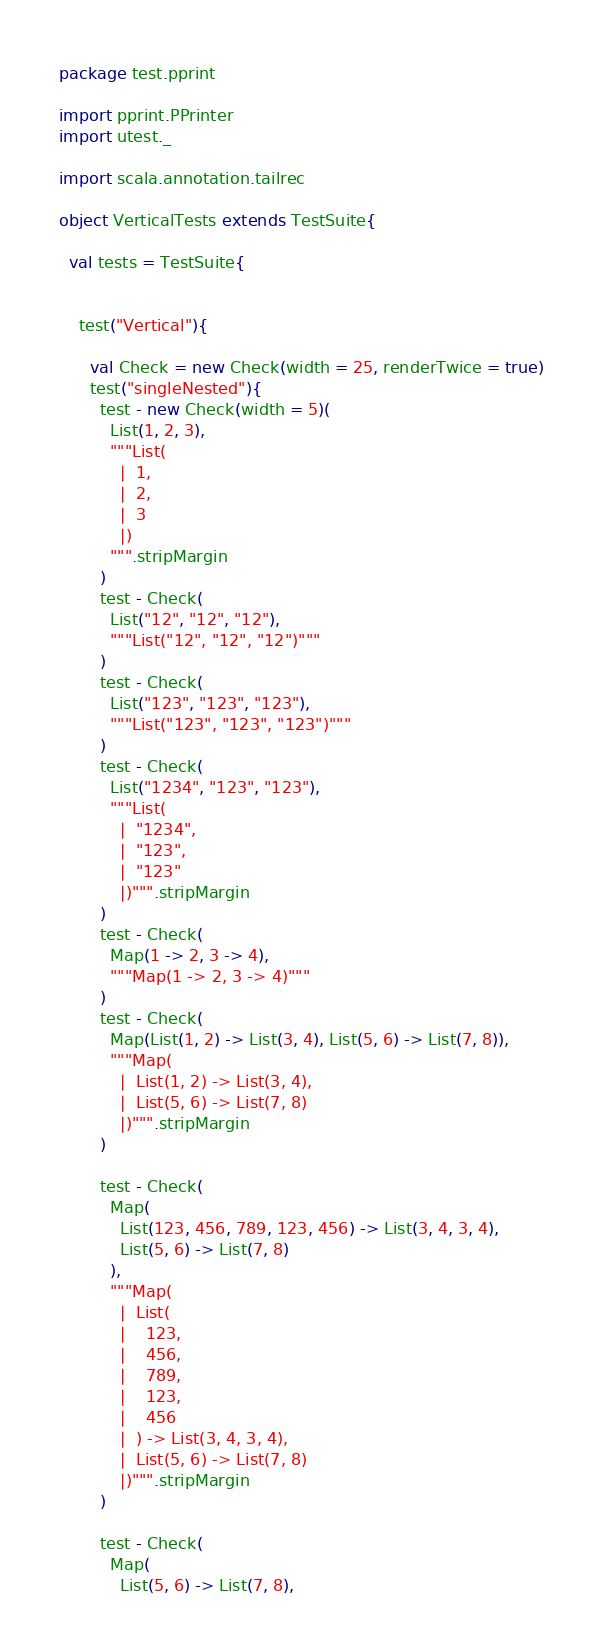<code> <loc_0><loc_0><loc_500><loc_500><_Scala_>package test.pprint

import pprint.PPrinter
import utest._

import scala.annotation.tailrec

object VerticalTests extends TestSuite{

  val tests = TestSuite{


    test("Vertical"){

      val Check = new Check(width = 25, renderTwice = true)
      test("singleNested"){
        test - new Check(width = 5)(
          List(1, 2, 3),
          """List(
            |  1,
            |  2,
            |  3
            |)
          """.stripMargin
        )
        test - Check(
          List("12", "12", "12"),
          """List("12", "12", "12")"""
        )
        test - Check(
          List("123", "123", "123"),
          """List("123", "123", "123")"""
        )
        test - Check(
          List("1234", "123", "123"),
          """List(
            |  "1234",
            |  "123",
            |  "123"
            |)""".stripMargin
        )
        test - Check(
          Map(1 -> 2, 3 -> 4),
          """Map(1 -> 2, 3 -> 4)"""
        )
        test - Check(
          Map(List(1, 2) -> List(3, 4), List(5, 6) -> List(7, 8)),
          """Map(
            |  List(1, 2) -> List(3, 4),
            |  List(5, 6) -> List(7, 8)
            |)""".stripMargin
        )

        test - Check(
          Map(
            List(123, 456, 789, 123, 456) -> List(3, 4, 3, 4),
            List(5, 6) -> List(7, 8)
          ),
          """Map(
            |  List(
            |    123,
            |    456,
            |    789,
            |    123,
            |    456
            |  ) -> List(3, 4, 3, 4),
            |  List(5, 6) -> List(7, 8)
            |)""".stripMargin
        )

        test - Check(
          Map(
            List(5, 6) -> List(7, 8),</code> 